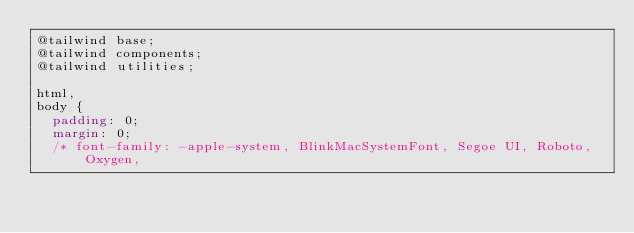<code> <loc_0><loc_0><loc_500><loc_500><_CSS_>@tailwind base;
@tailwind components;
@tailwind utilities;

html,
body {
  padding: 0;
  margin: 0;
  /* font-family: -apple-system, BlinkMacSystemFont, Segoe UI, Roboto, Oxygen,</code> 